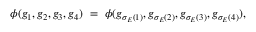Convert formula to latex. <formula><loc_0><loc_0><loc_500><loc_500>\phi ( g _ { 1 } , g _ { 2 } , g _ { 3 } , g _ { 4 } ) \ = \ \phi ( g _ { \sigma _ { E } ( 1 ) } , g _ { \sigma _ { E } ( 2 ) } , g _ { \sigma _ { E } ( 3 ) } , g _ { \sigma _ { E } ( 4 ) } ) ,</formula> 